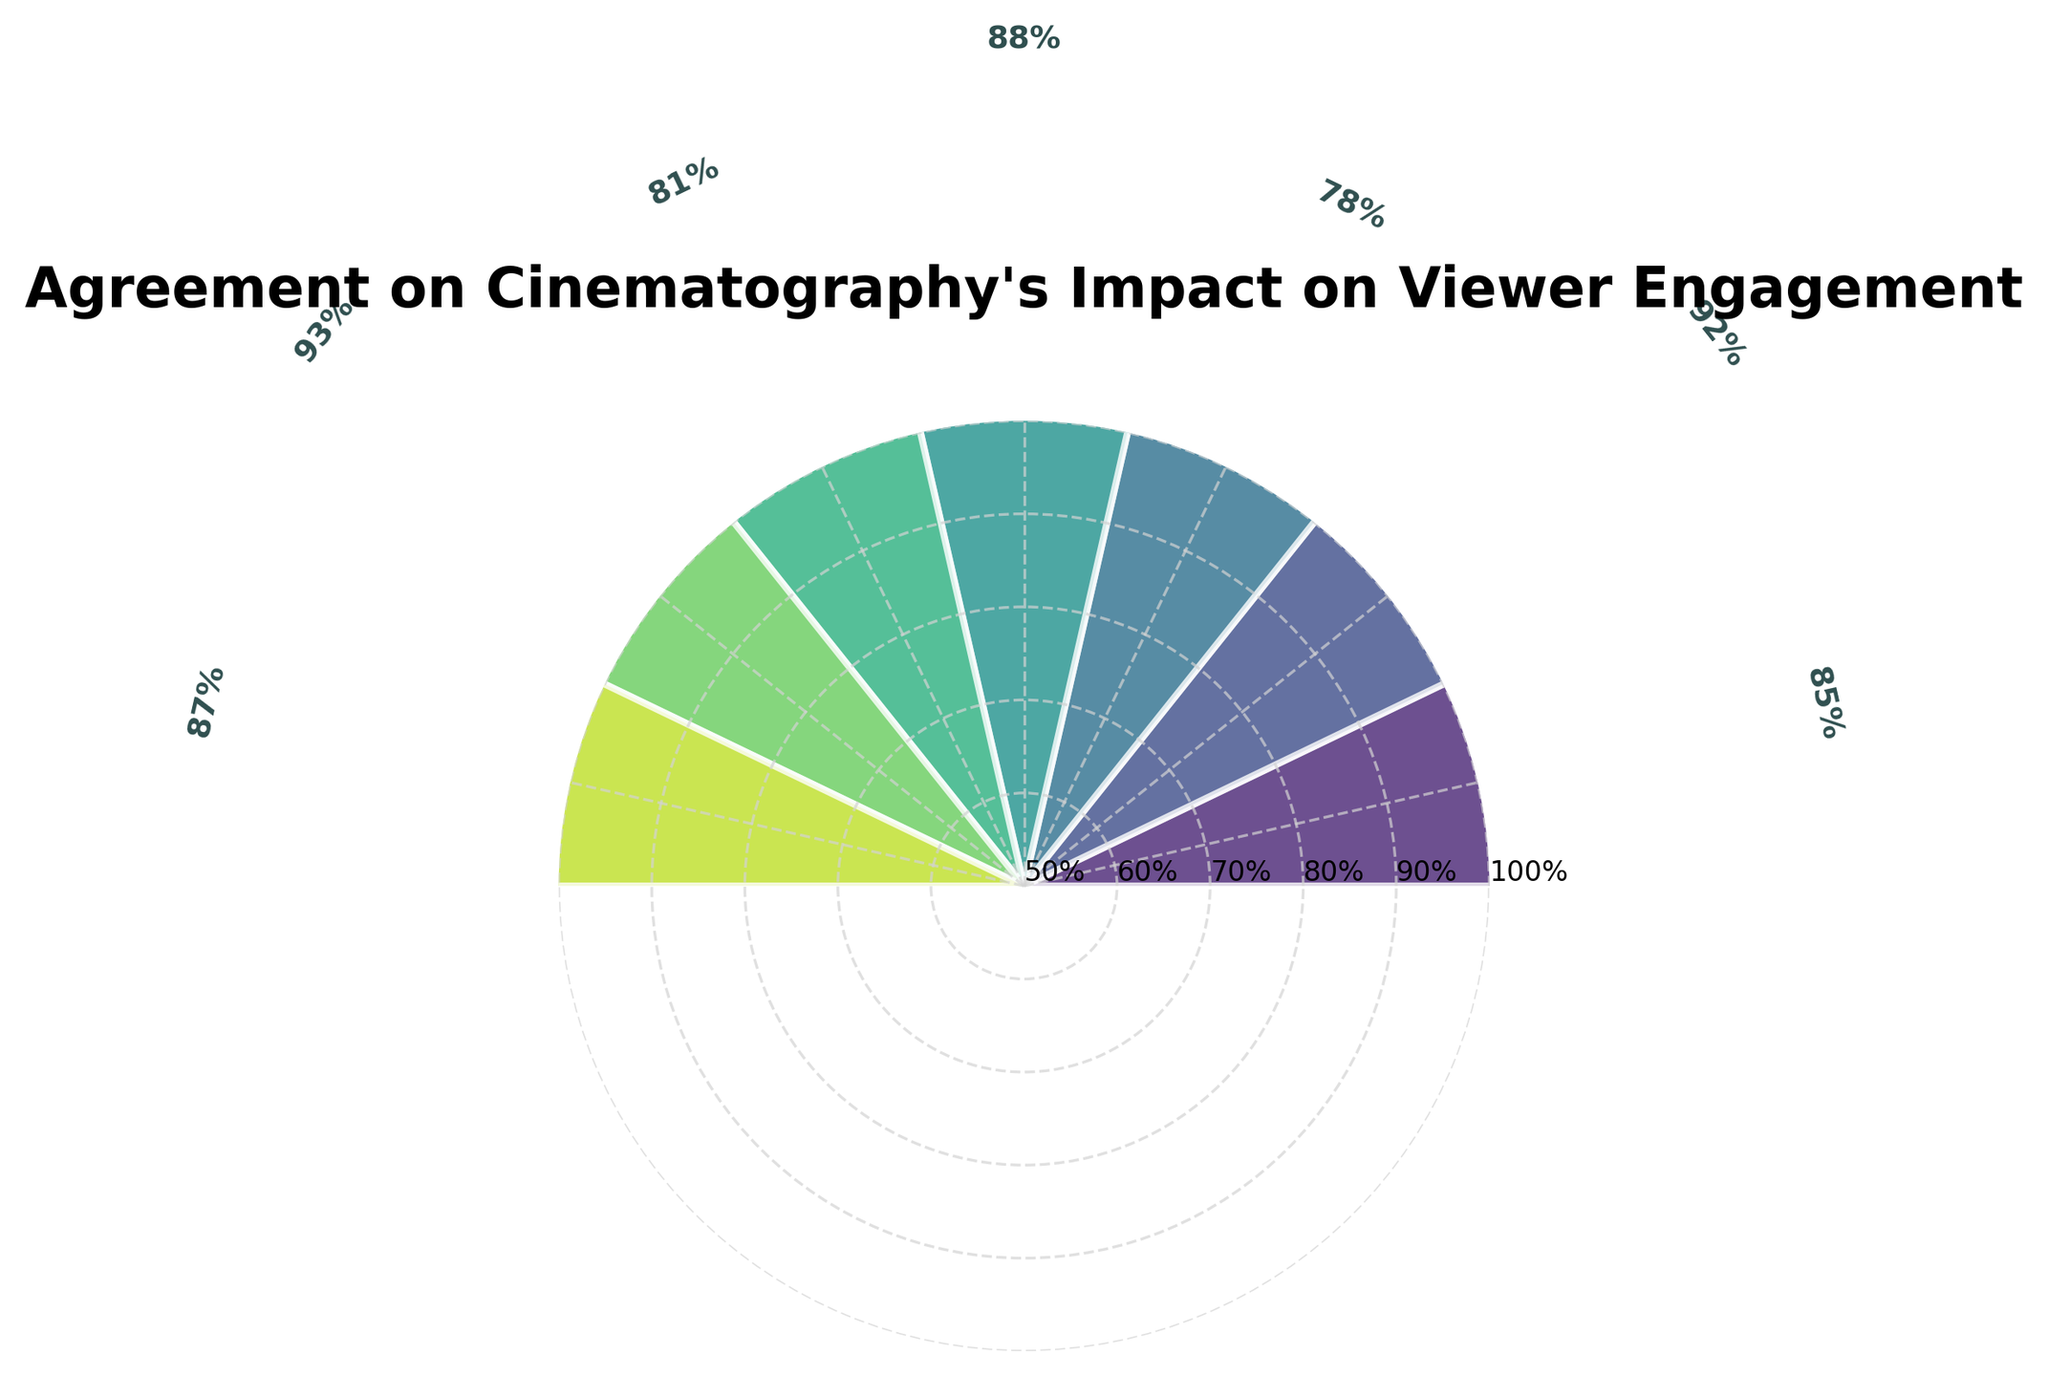what is the title of the figure? Look at the text displayed at the top of the figure.
Answer: Agreement on Cinematography's Impact on Viewer Engagement Which film critics group shows the highest agreement percentage on the impact of cinematography on viewer engagement? Compare the heights of the bars on the chart to identify the highest one.
Answer: Online Film Critics Society What percentage of agreement does the New York Film Critics Circle have? Locate the New York Film Critics Circle on the chart and check the agreement percentage displayed next to its bar.
Answer: 78% What is the difference in agreement percentages between the Roger Ebert Fellows and the National Society of Film Critics? Subtract the agreement percentage of the National Society of Film Critics from that of the Roger Ebert Fellows (92% - 81%).
Answer: 11% Which group has a higher agreement percentage: International Federation of Film Critics or Los Angeles Film Critics Association? Compare the heights of the bars representing these two groups.
Answer: Los Angeles Film Critics Association What is the average agreement percentage for all the groups in the figure? Sum all the agreement percentages (85 + 92 + 78 + 88 + 81 + 93 + 87) and divide by the number of groups (7).  Sum = 604, Average = 604/7.
Answer: 86.29% How many film critics groups have an agreement percentage of 85% or more? Count all bars that represent an agreement percentage of 85% or higher.
Answer: 5 Which critics group has the closest agreement percentage to 80%? Compare all the agreement percentages to find the one nearest to 80%.
Answer: National Society of Film Critics Does any group's agreement percentage fall below 75%? Check if any of the bars represent an agreement percentage below 75%.
Answer: No What's the range of agreement percentages displayed in the figure? Subtract the smallest agreement percentage from the largest one (93 - 78).
Answer: 15% 